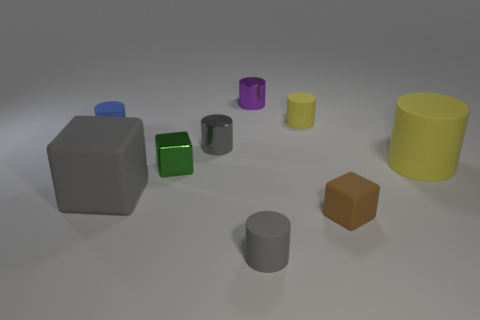Subtract all yellow cylinders. How many cylinders are left? 4 Subtract all yellow cylinders. How many cylinders are left? 4 Subtract all red cylinders. Subtract all purple blocks. How many cylinders are left? 6 Add 1 small cyan cylinders. How many objects exist? 10 Subtract all blocks. How many objects are left? 6 Add 6 metallic cubes. How many metallic cubes are left? 7 Add 1 blocks. How many blocks exist? 4 Subtract 0 purple spheres. How many objects are left? 9 Subtract all big green spheres. Subtract all tiny brown things. How many objects are left? 8 